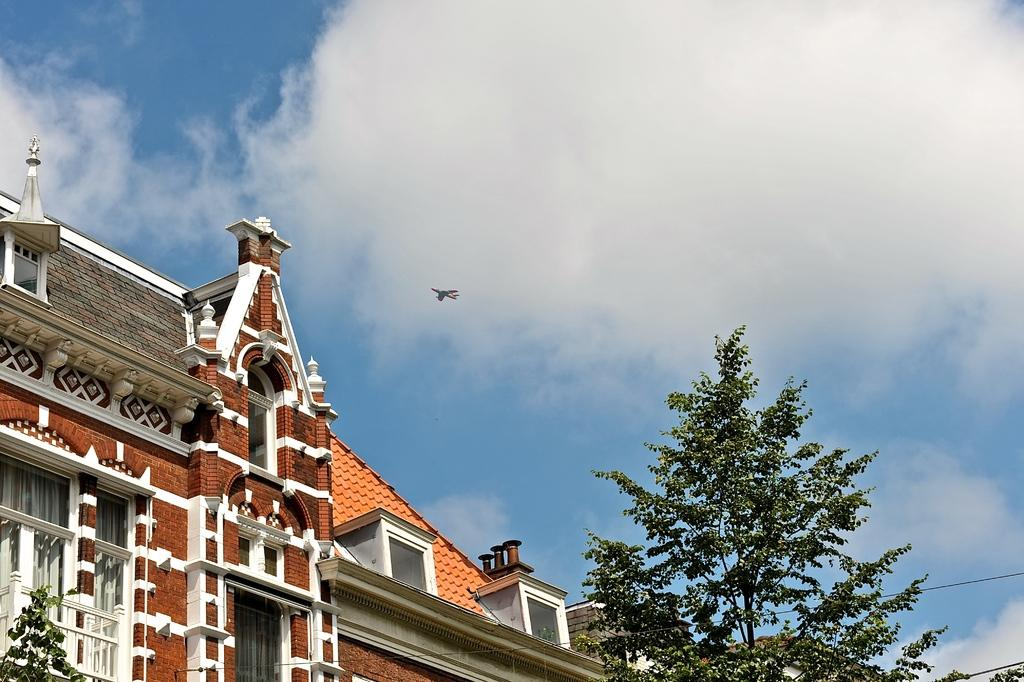What type of structure is present in the image? There is a building in the image. What colors can be seen on the building? The building is white and brown in color. What is located in front of the building? There are trees in front of the building. What can be seen in the background of the image? There is an aircraft and clouds in the background of the image. What else is visible in the background of the image? The sky is visible in the background of the image. How many clocks are hanging on the edge of the building in the image? There are no clocks visible on the edge of the building in the image. Are there any boats present in the image? There are no boats present in the image. 